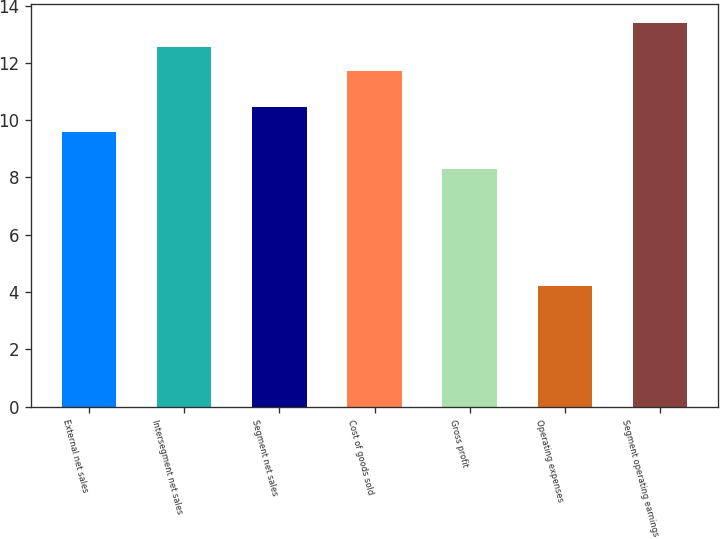<chart> <loc_0><loc_0><loc_500><loc_500><bar_chart><fcel>External net sales<fcel>Intersegment net sales<fcel>Segment net sales<fcel>Cost of goods sold<fcel>Gross profit<fcel>Operating expenses<fcel>Segment operating earnings<nl><fcel>9.6<fcel>12.55<fcel>10.45<fcel>11.7<fcel>8.3<fcel>4.2<fcel>13.4<nl></chart> 